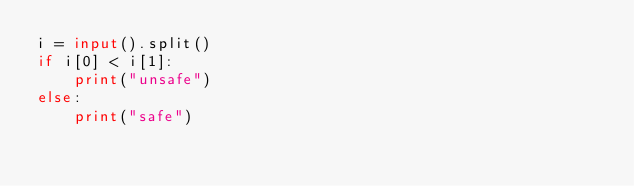<code> <loc_0><loc_0><loc_500><loc_500><_Python_>i = input().split()
if i[0] < i[1]:
    print("unsafe")
else:
    print("safe")</code> 